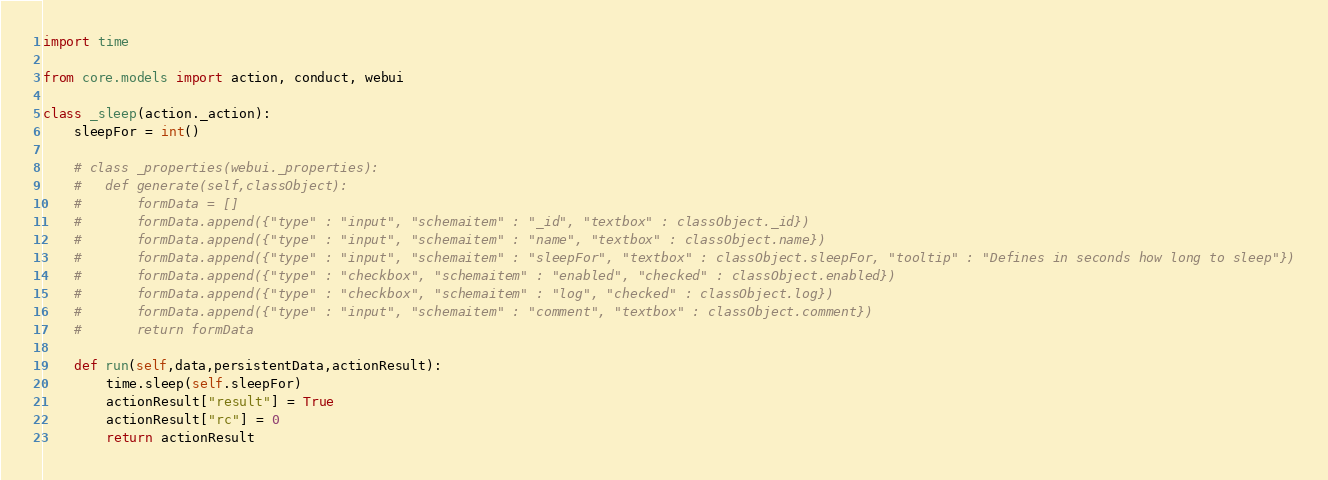Convert code to text. <code><loc_0><loc_0><loc_500><loc_500><_Python_>import time

from core.models import action, conduct, webui

class _sleep(action._action):
	sleepFor = int()

	# class _properties(webui._properties):
	# 	def generate(self,classObject):
	# 		formData = []
	# 		formData.append({"type" : "input", "schemaitem" : "_id", "textbox" : classObject._id})
	# 		formData.append({"type" : "input", "schemaitem" : "name", "textbox" : classObject.name})
	# 		formData.append({"type" : "input", "schemaitem" : "sleepFor", "textbox" : classObject.sleepFor, "tooltip" : "Defines in seconds how long to sleep"})
	# 		formData.append({"type" : "checkbox", "schemaitem" : "enabled", "checked" : classObject.enabled})
	# 		formData.append({"type" : "checkbox", "schemaitem" : "log", "checked" : classObject.log})
	# 		formData.append({"type" : "input", "schemaitem" : "comment", "textbox" : classObject.comment})
	# 		return formData

	def run(self,data,persistentData,actionResult):
		time.sleep(self.sleepFor)
		actionResult["result"] = True
		actionResult["rc"] = 0
		return actionResult
</code> 